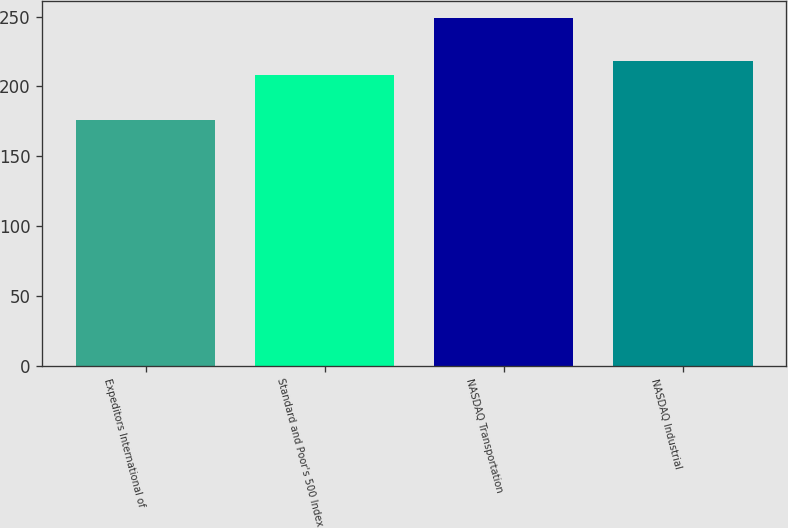Convert chart to OTSL. <chart><loc_0><loc_0><loc_500><loc_500><bar_chart><fcel>Expeditors International of<fcel>Standard and Poor's 500 Index<fcel>NASDAQ Transportation<fcel>NASDAQ Industrial<nl><fcel>176.08<fcel>208.14<fcel>248.92<fcel>218.34<nl></chart> 